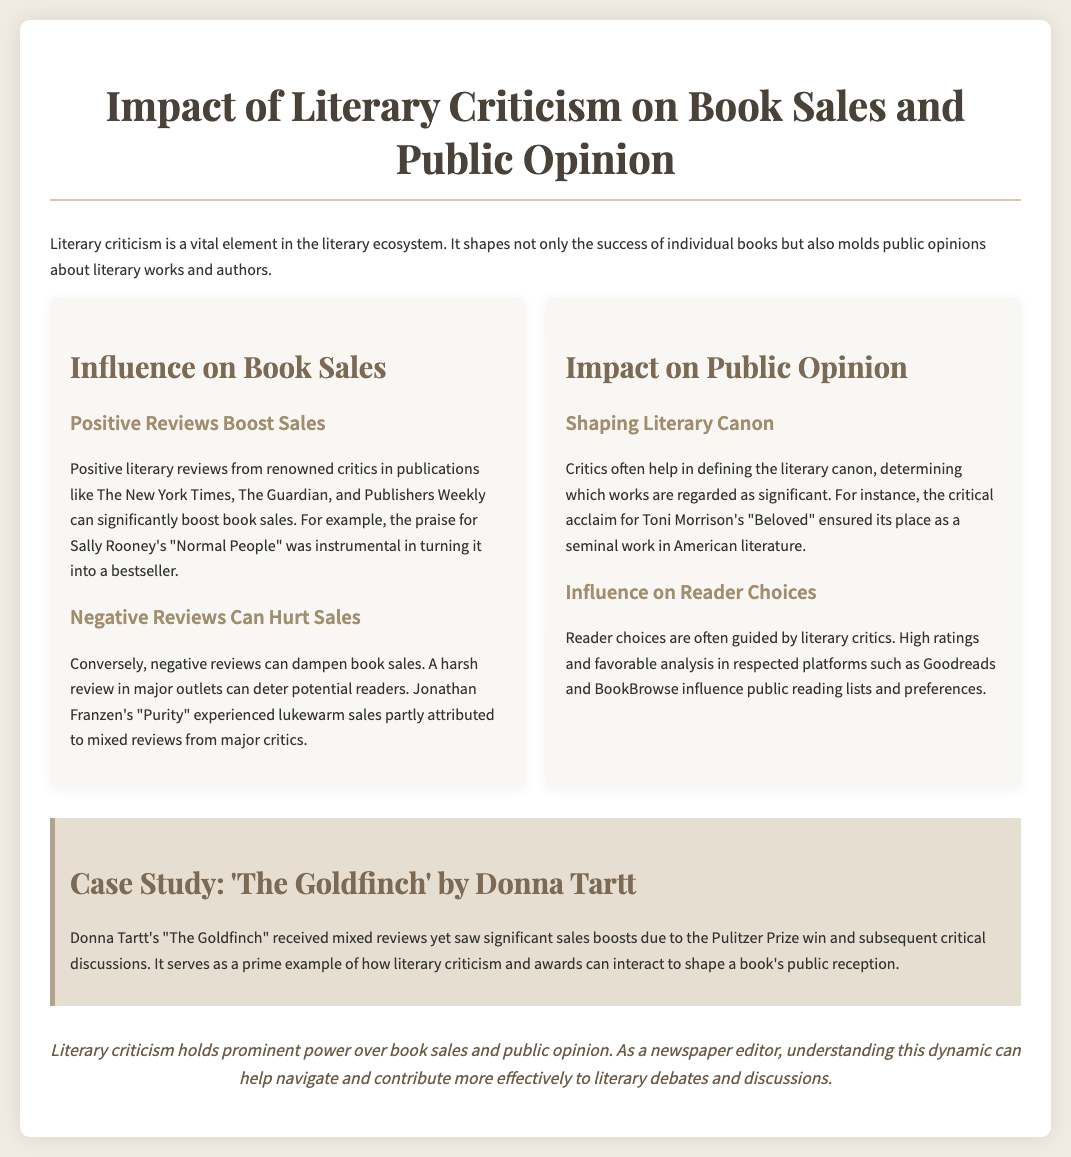What is the title of the presentation? The title of the presentation is stated at the top of the document.
Answer: Impact of Literary Criticism on Book Sales and Public Opinion Which book is mentioned as a prime example of positive reviews boosting sales? The document provides a specific example of a book benefited from positive reviews.
Answer: Normal People What recognition did 'The Goldfinch' receive? The document mentions a significant award related to 'The Goldfinch.'
Answer: Pulitzer Prize Which author is highlighted for their influence on defining the literary canon? The document specifies an author noted for their critical acclaim and significance in literature.
Answer: Toni Morrison What type of reviews can hurt book sales according to the presentation? The document distinguishes between positive and negative influences on sales in its content.
Answer: Negative reviews What do positive reviews from renowned critics lead to? The document explains the outcome of positive reviews in relation to book sales.
Answer: Boosted sales How is the case study labeled in the document? The document specifically identifies the case study format for emphasis.
Answer: Case Study What influence do critics have on reader choices? The document discusses how critics affect public preferences in reading.
Answer: Guide reader choices 